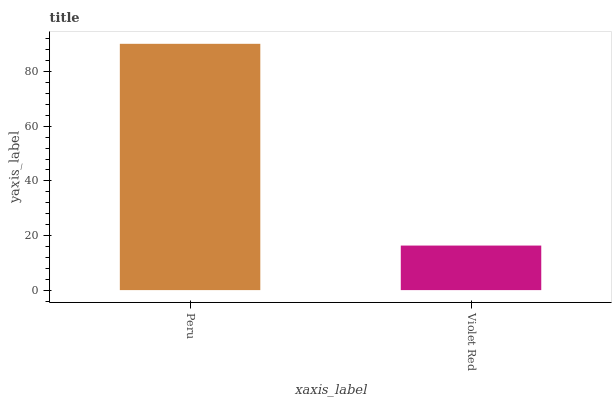Is Violet Red the minimum?
Answer yes or no. Yes. Is Peru the maximum?
Answer yes or no. Yes. Is Violet Red the maximum?
Answer yes or no. No. Is Peru greater than Violet Red?
Answer yes or no. Yes. Is Violet Red less than Peru?
Answer yes or no. Yes. Is Violet Red greater than Peru?
Answer yes or no. No. Is Peru less than Violet Red?
Answer yes or no. No. Is Peru the high median?
Answer yes or no. Yes. Is Violet Red the low median?
Answer yes or no. Yes. Is Violet Red the high median?
Answer yes or no. No. Is Peru the low median?
Answer yes or no. No. 